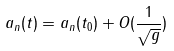<formula> <loc_0><loc_0><loc_500><loc_500>a _ { n } ( t ) = a _ { n } ( t _ { 0 } ) + O ( \frac { 1 } { \sqrt { g } } )</formula> 